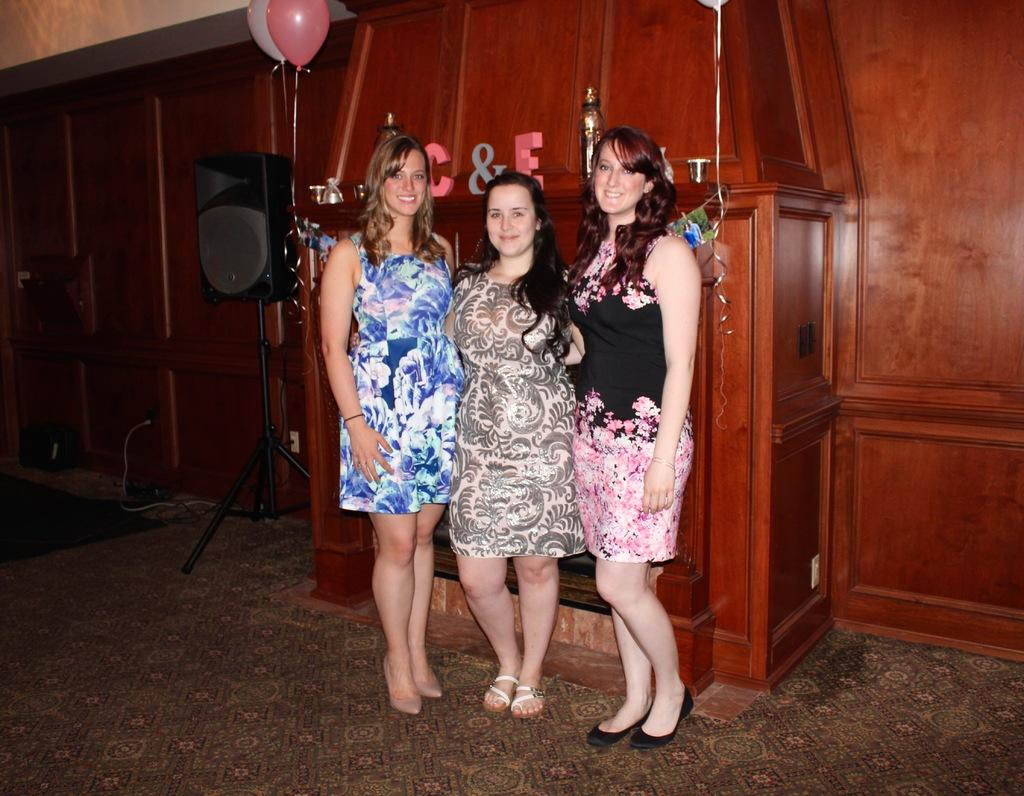How many women are in the image? There are three women in the image. What expression do the women have? The women are smiling. What can be seen behind the women? There are two objects in a wooden structure behind the women. What device is present in the image for amplifying sound? There is a speaker in the image. What decorative items are present in the image? There are balloons in the image. What type of oil is being used by the women in the image? There is no oil present in the image, and the women are not using any oil. How many brothers are visible in the image? There are no brothers present in the image; it features three women. 